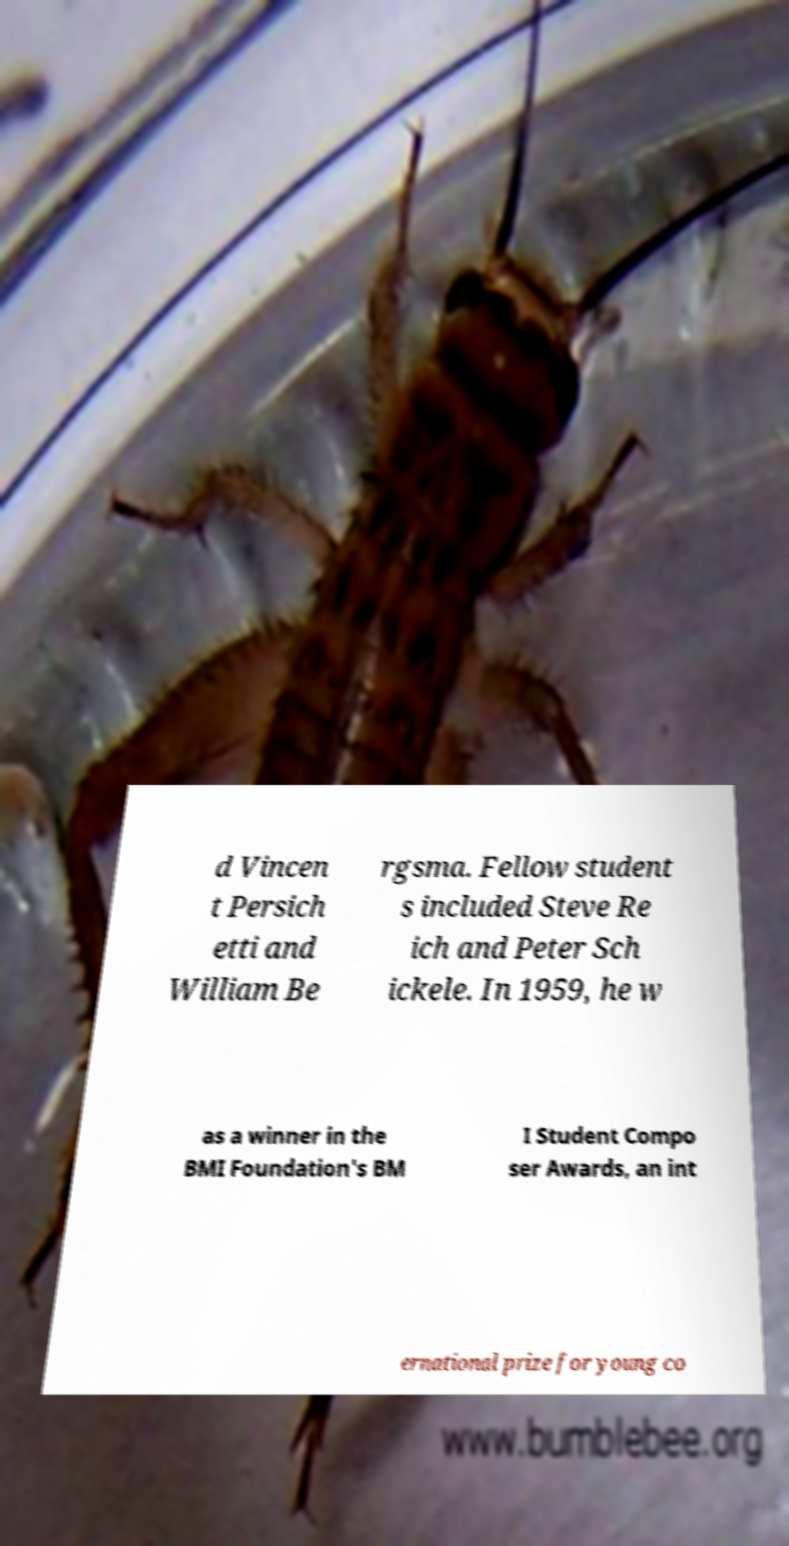There's text embedded in this image that I need extracted. Can you transcribe it verbatim? d Vincen t Persich etti and William Be rgsma. Fellow student s included Steve Re ich and Peter Sch ickele. In 1959, he w as a winner in the BMI Foundation's BM I Student Compo ser Awards, an int ernational prize for young co 